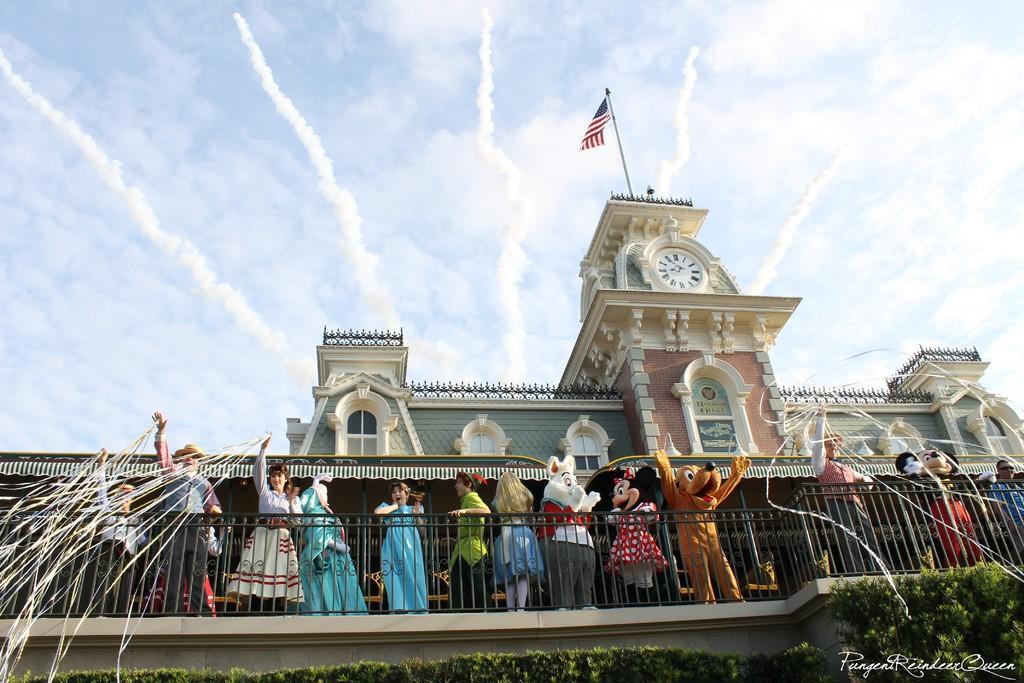How would you summarize this image in a sentence or two? In this image I can see few people are standing to the side of the railing. I can also see few people wearing the costumes. These people wearing the different color dresses. In the back I can see the building and the clock and flag to that. In the back I can see the clouds and the sky. 